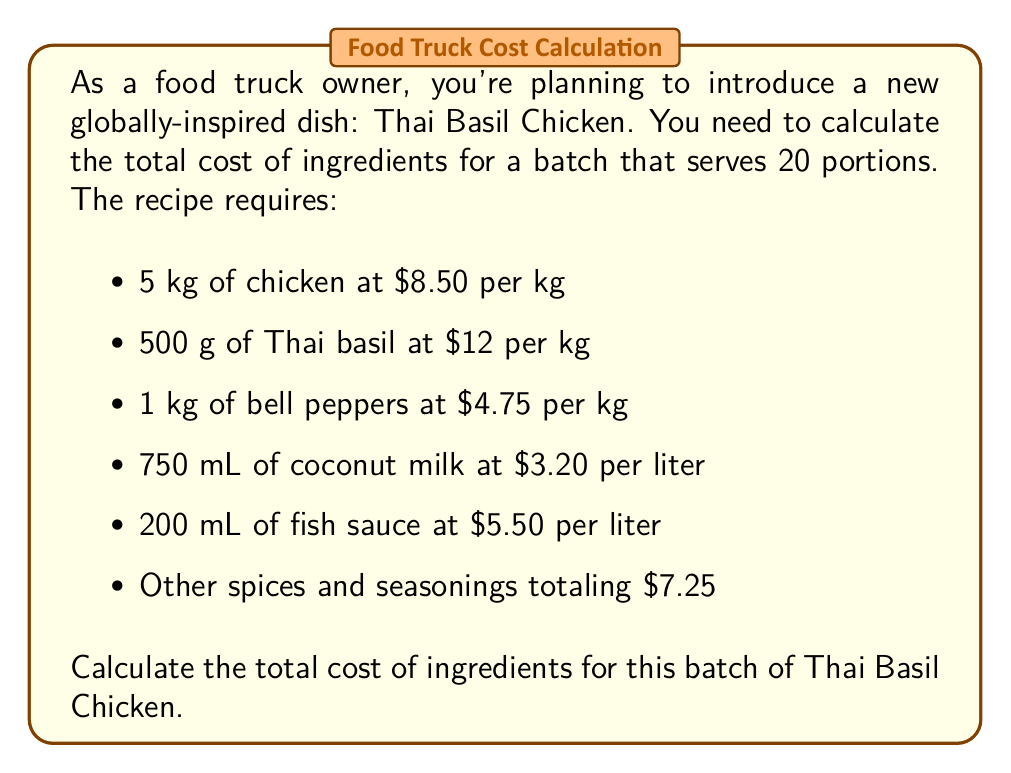Solve this math problem. Let's break down the cost calculation for each ingredient:

1. Chicken:
   $5 \text{ kg} \times \$8.50/\text{kg} = \$42.50$

2. Thai basil:
   $500 \text{ g} = 0.5 \text{ kg}$
   $0.5 \text{ kg} \times \$12/\text{kg} = \$6.00$

3. Bell peppers:
   $1 \text{ kg} \times \$4.75/\text{kg} = \$4.75$

4. Coconut milk:
   $750 \text{ mL} = 0.75 \text{ L}$
   $0.75 \text{ L} \times \$3.20/\text{L} = \$2.40$

5. Fish sauce:
   $200 \text{ mL} = 0.2 \text{ L}$
   $0.2 \text{ L} \times \$5.50/\text{L} = \$1.10$

6. Other spices and seasonings:
   $\$7.25$ (given)

Now, let's sum up all the ingredient costs:

$$\text{Total cost} = \$42.50 + \$6.00 + \$4.75 + \$2.40 + \$1.10 + \$7.25$$

$$\text{Total cost} = \$64.00$$
Answer: $64.00 